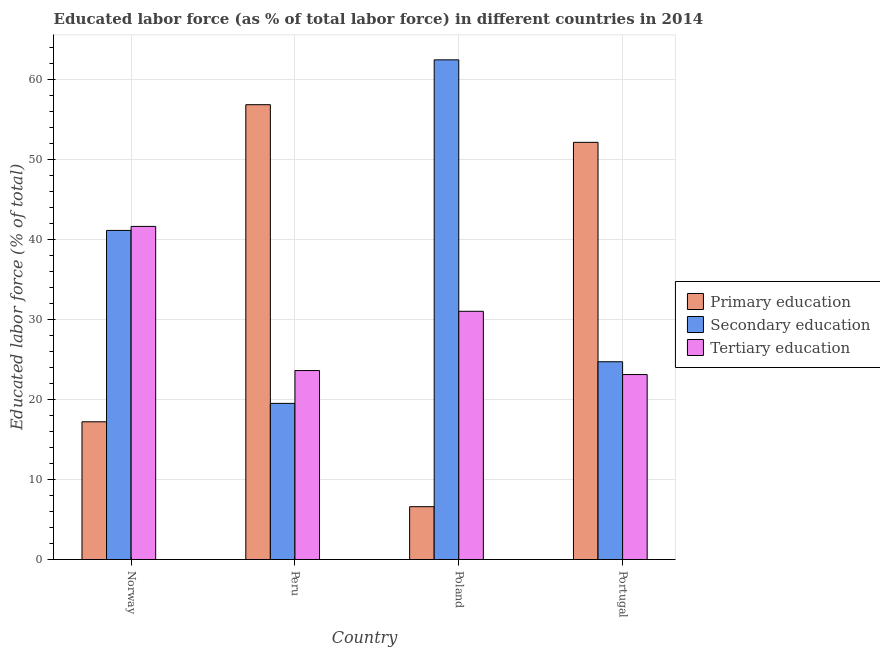How many groups of bars are there?
Your answer should be very brief. 4. How many bars are there on the 4th tick from the right?
Your answer should be compact. 3. What is the label of the 4th group of bars from the left?
Provide a succinct answer. Portugal. In how many cases, is the number of bars for a given country not equal to the number of legend labels?
Offer a terse response. 0. What is the percentage of labor force who received tertiary education in Peru?
Offer a very short reply. 23.6. Across all countries, what is the maximum percentage of labor force who received primary education?
Make the answer very short. 56.8. Across all countries, what is the minimum percentage of labor force who received primary education?
Provide a short and direct response. 6.6. In which country was the percentage of labor force who received tertiary education maximum?
Ensure brevity in your answer.  Norway. In which country was the percentage of labor force who received primary education minimum?
Offer a terse response. Poland. What is the total percentage of labor force who received tertiary education in the graph?
Offer a terse response. 119.3. What is the difference between the percentage of labor force who received tertiary education in Norway and that in Poland?
Your answer should be compact. 10.6. What is the difference between the percentage of labor force who received secondary education in Portugal and the percentage of labor force who received primary education in Norway?
Your answer should be compact. 7.5. What is the average percentage of labor force who received primary education per country?
Ensure brevity in your answer.  33.17. What is the difference between the percentage of labor force who received secondary education and percentage of labor force who received tertiary education in Portugal?
Your answer should be very brief. 1.6. In how many countries, is the percentage of labor force who received secondary education greater than 30 %?
Ensure brevity in your answer.  2. What is the ratio of the percentage of labor force who received primary education in Poland to that in Portugal?
Make the answer very short. 0.13. Is the percentage of labor force who received secondary education in Poland less than that in Portugal?
Your answer should be compact. No. Is the difference between the percentage of labor force who received tertiary education in Norway and Peru greater than the difference between the percentage of labor force who received primary education in Norway and Peru?
Provide a succinct answer. Yes. What is the difference between the highest and the second highest percentage of labor force who received primary education?
Your answer should be compact. 4.7. What is the difference between the highest and the lowest percentage of labor force who received secondary education?
Provide a succinct answer. 42.9. Is the sum of the percentage of labor force who received tertiary education in Poland and Portugal greater than the maximum percentage of labor force who received primary education across all countries?
Offer a terse response. No. What does the 3rd bar from the left in Peru represents?
Your answer should be very brief. Tertiary education. Is it the case that in every country, the sum of the percentage of labor force who received primary education and percentage of labor force who received secondary education is greater than the percentage of labor force who received tertiary education?
Provide a short and direct response. Yes. Are all the bars in the graph horizontal?
Give a very brief answer. No. How many countries are there in the graph?
Give a very brief answer. 4. What is the difference between two consecutive major ticks on the Y-axis?
Provide a short and direct response. 10. Does the graph contain any zero values?
Your response must be concise. No. Does the graph contain grids?
Keep it short and to the point. Yes. How many legend labels are there?
Provide a succinct answer. 3. How are the legend labels stacked?
Make the answer very short. Vertical. What is the title of the graph?
Keep it short and to the point. Educated labor force (as % of total labor force) in different countries in 2014. Does "Ores and metals" appear as one of the legend labels in the graph?
Your answer should be very brief. No. What is the label or title of the Y-axis?
Give a very brief answer. Educated labor force (% of total). What is the Educated labor force (% of total) in Primary education in Norway?
Make the answer very short. 17.2. What is the Educated labor force (% of total) in Secondary education in Norway?
Your answer should be compact. 41.1. What is the Educated labor force (% of total) of Tertiary education in Norway?
Your response must be concise. 41.6. What is the Educated labor force (% of total) in Primary education in Peru?
Provide a succinct answer. 56.8. What is the Educated labor force (% of total) in Secondary education in Peru?
Offer a very short reply. 19.5. What is the Educated labor force (% of total) of Tertiary education in Peru?
Provide a succinct answer. 23.6. What is the Educated labor force (% of total) in Primary education in Poland?
Your response must be concise. 6.6. What is the Educated labor force (% of total) in Secondary education in Poland?
Your response must be concise. 62.4. What is the Educated labor force (% of total) of Tertiary education in Poland?
Give a very brief answer. 31. What is the Educated labor force (% of total) in Primary education in Portugal?
Provide a short and direct response. 52.1. What is the Educated labor force (% of total) in Secondary education in Portugal?
Make the answer very short. 24.7. What is the Educated labor force (% of total) of Tertiary education in Portugal?
Your answer should be compact. 23.1. Across all countries, what is the maximum Educated labor force (% of total) in Primary education?
Keep it short and to the point. 56.8. Across all countries, what is the maximum Educated labor force (% of total) of Secondary education?
Offer a terse response. 62.4. Across all countries, what is the maximum Educated labor force (% of total) of Tertiary education?
Make the answer very short. 41.6. Across all countries, what is the minimum Educated labor force (% of total) in Primary education?
Provide a succinct answer. 6.6. Across all countries, what is the minimum Educated labor force (% of total) of Tertiary education?
Ensure brevity in your answer.  23.1. What is the total Educated labor force (% of total) of Primary education in the graph?
Provide a short and direct response. 132.7. What is the total Educated labor force (% of total) of Secondary education in the graph?
Ensure brevity in your answer.  147.7. What is the total Educated labor force (% of total) of Tertiary education in the graph?
Keep it short and to the point. 119.3. What is the difference between the Educated labor force (% of total) of Primary education in Norway and that in Peru?
Ensure brevity in your answer.  -39.6. What is the difference between the Educated labor force (% of total) in Secondary education in Norway and that in Peru?
Ensure brevity in your answer.  21.6. What is the difference between the Educated labor force (% of total) in Secondary education in Norway and that in Poland?
Offer a very short reply. -21.3. What is the difference between the Educated labor force (% of total) of Tertiary education in Norway and that in Poland?
Provide a succinct answer. 10.6. What is the difference between the Educated labor force (% of total) of Primary education in Norway and that in Portugal?
Ensure brevity in your answer.  -34.9. What is the difference between the Educated labor force (% of total) in Secondary education in Norway and that in Portugal?
Give a very brief answer. 16.4. What is the difference between the Educated labor force (% of total) in Primary education in Peru and that in Poland?
Provide a succinct answer. 50.2. What is the difference between the Educated labor force (% of total) of Secondary education in Peru and that in Poland?
Ensure brevity in your answer.  -42.9. What is the difference between the Educated labor force (% of total) of Tertiary education in Peru and that in Poland?
Keep it short and to the point. -7.4. What is the difference between the Educated labor force (% of total) in Primary education in Peru and that in Portugal?
Give a very brief answer. 4.7. What is the difference between the Educated labor force (% of total) of Secondary education in Peru and that in Portugal?
Ensure brevity in your answer.  -5.2. What is the difference between the Educated labor force (% of total) of Tertiary education in Peru and that in Portugal?
Provide a short and direct response. 0.5. What is the difference between the Educated labor force (% of total) of Primary education in Poland and that in Portugal?
Offer a terse response. -45.5. What is the difference between the Educated labor force (% of total) in Secondary education in Poland and that in Portugal?
Provide a succinct answer. 37.7. What is the difference between the Educated labor force (% of total) in Tertiary education in Poland and that in Portugal?
Give a very brief answer. 7.9. What is the difference between the Educated labor force (% of total) of Secondary education in Norway and the Educated labor force (% of total) of Tertiary education in Peru?
Make the answer very short. 17.5. What is the difference between the Educated labor force (% of total) in Primary education in Norway and the Educated labor force (% of total) in Secondary education in Poland?
Make the answer very short. -45.2. What is the difference between the Educated labor force (% of total) in Primary education in Norway and the Educated labor force (% of total) in Tertiary education in Poland?
Your answer should be compact. -13.8. What is the difference between the Educated labor force (% of total) in Primary education in Norway and the Educated labor force (% of total) in Secondary education in Portugal?
Your answer should be very brief. -7.5. What is the difference between the Educated labor force (% of total) of Primary education in Peru and the Educated labor force (% of total) of Tertiary education in Poland?
Your response must be concise. 25.8. What is the difference between the Educated labor force (% of total) of Primary education in Peru and the Educated labor force (% of total) of Secondary education in Portugal?
Provide a succinct answer. 32.1. What is the difference between the Educated labor force (% of total) of Primary education in Peru and the Educated labor force (% of total) of Tertiary education in Portugal?
Your response must be concise. 33.7. What is the difference between the Educated labor force (% of total) of Secondary education in Peru and the Educated labor force (% of total) of Tertiary education in Portugal?
Provide a short and direct response. -3.6. What is the difference between the Educated labor force (% of total) in Primary education in Poland and the Educated labor force (% of total) in Secondary education in Portugal?
Give a very brief answer. -18.1. What is the difference between the Educated labor force (% of total) in Primary education in Poland and the Educated labor force (% of total) in Tertiary education in Portugal?
Your answer should be very brief. -16.5. What is the difference between the Educated labor force (% of total) in Secondary education in Poland and the Educated labor force (% of total) in Tertiary education in Portugal?
Offer a very short reply. 39.3. What is the average Educated labor force (% of total) of Primary education per country?
Give a very brief answer. 33.17. What is the average Educated labor force (% of total) in Secondary education per country?
Your answer should be compact. 36.92. What is the average Educated labor force (% of total) in Tertiary education per country?
Provide a short and direct response. 29.82. What is the difference between the Educated labor force (% of total) of Primary education and Educated labor force (% of total) of Secondary education in Norway?
Offer a very short reply. -23.9. What is the difference between the Educated labor force (% of total) of Primary education and Educated labor force (% of total) of Tertiary education in Norway?
Make the answer very short. -24.4. What is the difference between the Educated labor force (% of total) of Secondary education and Educated labor force (% of total) of Tertiary education in Norway?
Ensure brevity in your answer.  -0.5. What is the difference between the Educated labor force (% of total) in Primary education and Educated labor force (% of total) in Secondary education in Peru?
Provide a succinct answer. 37.3. What is the difference between the Educated labor force (% of total) in Primary education and Educated labor force (% of total) in Tertiary education in Peru?
Your answer should be very brief. 33.2. What is the difference between the Educated labor force (% of total) in Primary education and Educated labor force (% of total) in Secondary education in Poland?
Your answer should be very brief. -55.8. What is the difference between the Educated labor force (% of total) in Primary education and Educated labor force (% of total) in Tertiary education in Poland?
Make the answer very short. -24.4. What is the difference between the Educated labor force (% of total) of Secondary education and Educated labor force (% of total) of Tertiary education in Poland?
Offer a terse response. 31.4. What is the difference between the Educated labor force (% of total) in Primary education and Educated labor force (% of total) in Secondary education in Portugal?
Offer a terse response. 27.4. What is the ratio of the Educated labor force (% of total) in Primary education in Norway to that in Peru?
Your answer should be very brief. 0.3. What is the ratio of the Educated labor force (% of total) in Secondary education in Norway to that in Peru?
Provide a short and direct response. 2.11. What is the ratio of the Educated labor force (% of total) in Tertiary education in Norway to that in Peru?
Provide a short and direct response. 1.76. What is the ratio of the Educated labor force (% of total) of Primary education in Norway to that in Poland?
Provide a short and direct response. 2.61. What is the ratio of the Educated labor force (% of total) in Secondary education in Norway to that in Poland?
Give a very brief answer. 0.66. What is the ratio of the Educated labor force (% of total) of Tertiary education in Norway to that in Poland?
Make the answer very short. 1.34. What is the ratio of the Educated labor force (% of total) in Primary education in Norway to that in Portugal?
Keep it short and to the point. 0.33. What is the ratio of the Educated labor force (% of total) in Secondary education in Norway to that in Portugal?
Provide a succinct answer. 1.66. What is the ratio of the Educated labor force (% of total) of Tertiary education in Norway to that in Portugal?
Your answer should be compact. 1.8. What is the ratio of the Educated labor force (% of total) in Primary education in Peru to that in Poland?
Provide a short and direct response. 8.61. What is the ratio of the Educated labor force (% of total) of Secondary education in Peru to that in Poland?
Ensure brevity in your answer.  0.31. What is the ratio of the Educated labor force (% of total) of Tertiary education in Peru to that in Poland?
Keep it short and to the point. 0.76. What is the ratio of the Educated labor force (% of total) in Primary education in Peru to that in Portugal?
Keep it short and to the point. 1.09. What is the ratio of the Educated labor force (% of total) of Secondary education in Peru to that in Portugal?
Offer a terse response. 0.79. What is the ratio of the Educated labor force (% of total) in Tertiary education in Peru to that in Portugal?
Your answer should be very brief. 1.02. What is the ratio of the Educated labor force (% of total) in Primary education in Poland to that in Portugal?
Provide a succinct answer. 0.13. What is the ratio of the Educated labor force (% of total) of Secondary education in Poland to that in Portugal?
Give a very brief answer. 2.53. What is the ratio of the Educated labor force (% of total) in Tertiary education in Poland to that in Portugal?
Ensure brevity in your answer.  1.34. What is the difference between the highest and the second highest Educated labor force (% of total) of Secondary education?
Your response must be concise. 21.3. What is the difference between the highest and the lowest Educated labor force (% of total) of Primary education?
Your response must be concise. 50.2. What is the difference between the highest and the lowest Educated labor force (% of total) of Secondary education?
Your response must be concise. 42.9. What is the difference between the highest and the lowest Educated labor force (% of total) of Tertiary education?
Offer a terse response. 18.5. 